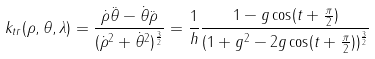<formula> <loc_0><loc_0><loc_500><loc_500>k _ { t r } ( \rho , \theta , \lambda ) = \frac { \dot { \rho } \ddot { \theta } - \dot { \theta } \ddot { \rho } } { ( \dot { \rho } ^ { 2 } + \dot { \theta } ^ { 2 } ) ^ { \frac { 3 } { 2 } } } = \frac { 1 } { h } \frac { 1 - g \cos ( t + \frac { \pi } { 2 } ) } { ( 1 + g ^ { 2 } - 2 g \cos ( t + \frac { \pi } { 2 } ) ) ^ { \frac { 3 } { 2 } } }</formula> 